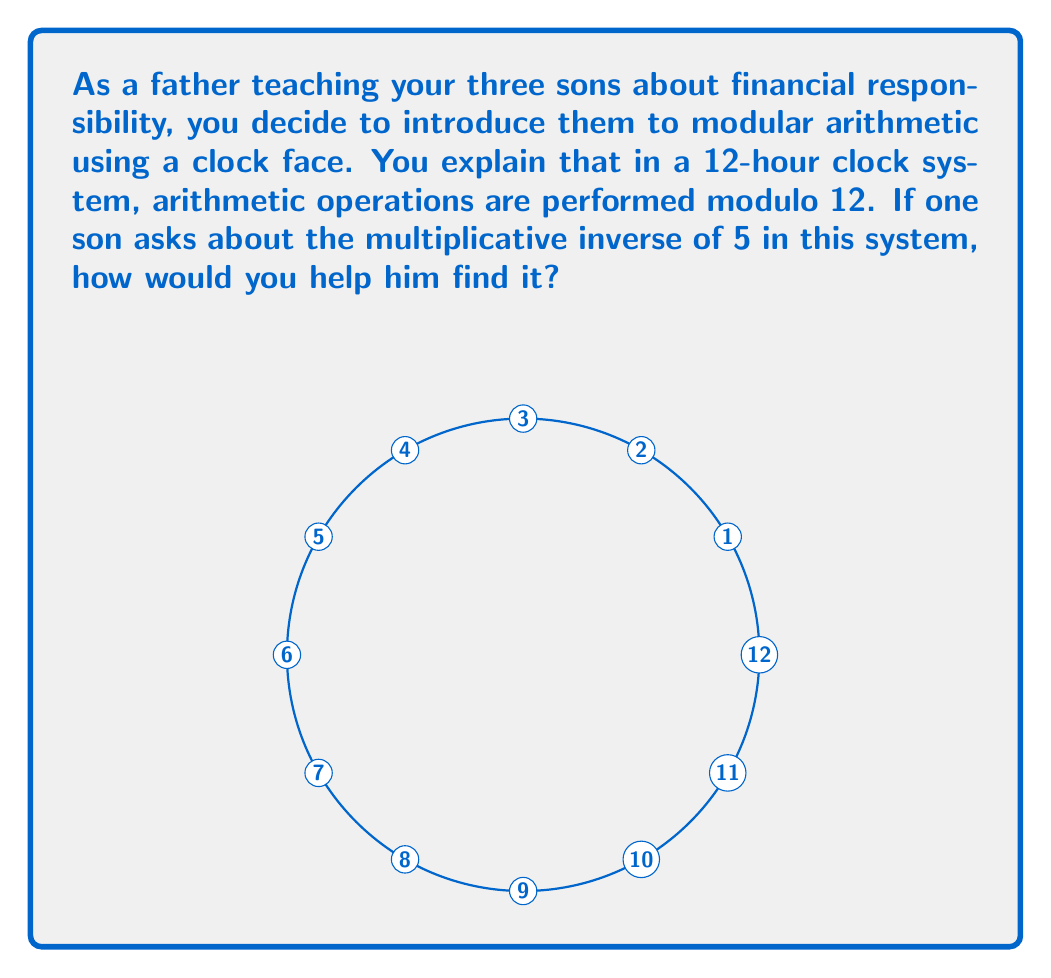Help me with this question. To find the multiplicative inverse of 5 in the ring $\mathbb{Z}_{12}$ (integers modulo 12), we need to find a number $x$ such that:

$$5x \equiv 1 \pmod{12}$$

Let's approach this step-by-step:

1) We can rewrite this as an equation:
   $$5x = 12k + 1$$
   where $k$ is some integer.

2) Rearranging the equation:
   $$5x - 12k = 1$$

3) This is a linear Diophantine equation. We can solve it using the extended Euclidean algorithm:

   $12 = 2 \times 5 + 2$
   $5 = 2 \times 2 + 1$
   $2 = 2 \times 1 + 0$

4) Working backwards:
   $1 = 5 - 2 \times 2$
   $1 = 5 - 2 \times (12 - 2 \times 5) = 5 \times 5 - 2 \times 12$

5) Therefore, $x = 5$ and $k = -2$ is a solution.

6) In $\mathbb{Z}_{12}$, $5$ is equivalent to $-7$ (since $5 + 7 = 12$).

Thus, $5 \times 5 \equiv 1 \pmod{12}$, so 5 is its own multiplicative inverse in $\mathbb{Z}_{12}$.

You can verify: $5 \times 5 = 25 \equiv 1 \pmod{12}$
Answer: $5$ 